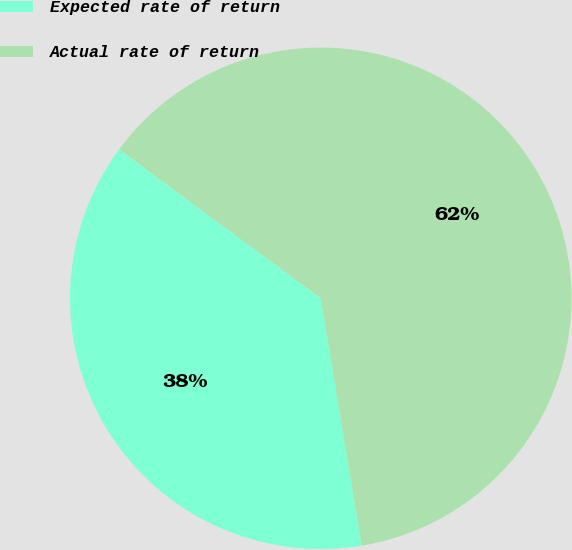Convert chart to OTSL. <chart><loc_0><loc_0><loc_500><loc_500><pie_chart><fcel>Expected rate of return<fcel>Actual rate of return<nl><fcel>37.74%<fcel>62.26%<nl></chart> 